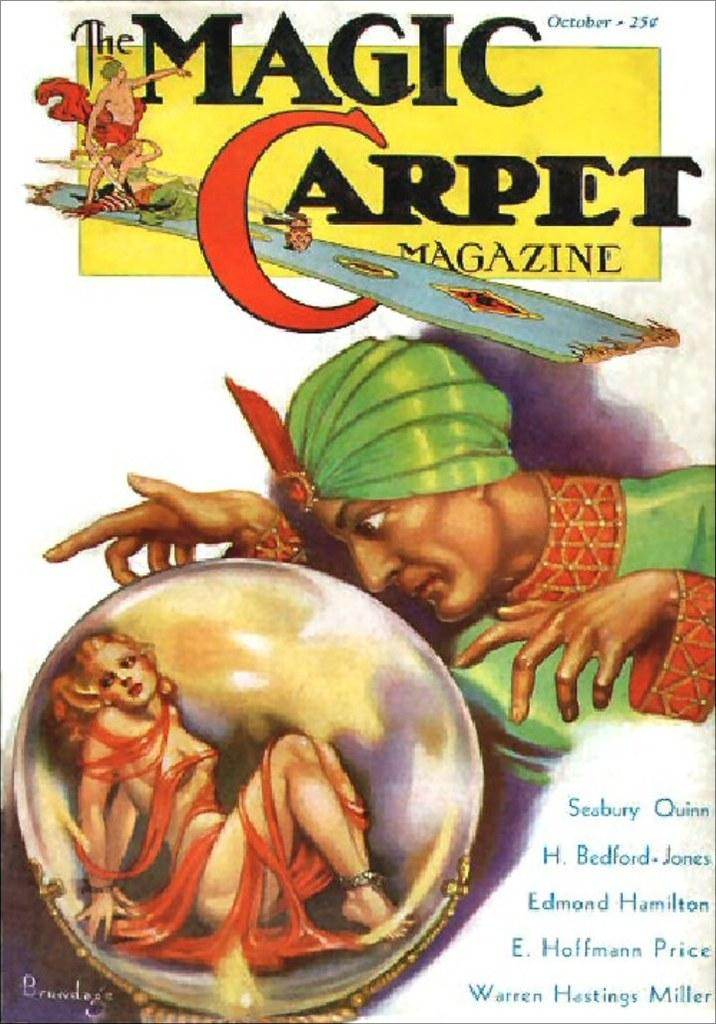What is present on the poster in the image? The poster contains images and text. What is the color of the background in the image? The background of the image is white. Can you see a tub filled with basketballs in the image? No, there is no tub or basketballs present in the image. Is there a donkey standing next to the poster in the image? No, there is no donkey present in the image. 